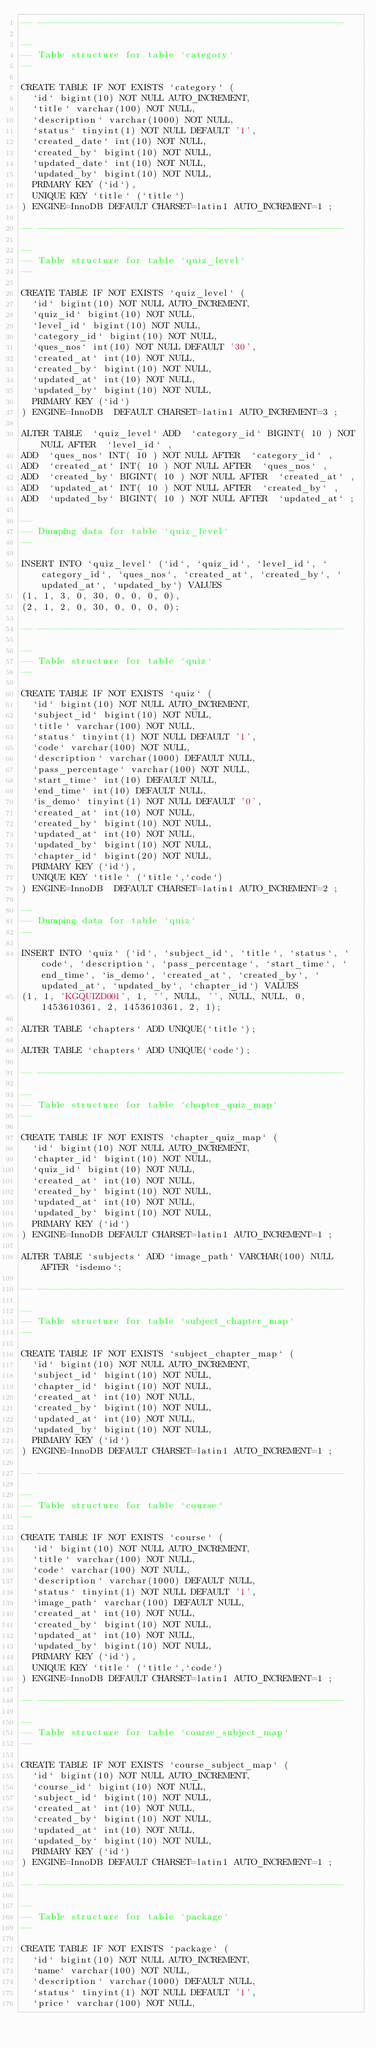<code> <loc_0><loc_0><loc_500><loc_500><_SQL_>-- --------------------------------------------------------

--
-- Table structure for table `category`
--

CREATE TABLE IF NOT EXISTS `category` (
  `id` bigint(10) NOT NULL AUTO_INCREMENT,
  `title` varchar(100) NOT NULL,
  `description` varchar(1000) NOT NULL,
  `status` tinyint(1) NOT NULL DEFAULT '1',
  `created_date` int(10) NOT NULL,
  `created_by` bigint(10) NOT NULL,
  `updated_date` int(10) NOT NULL,
  `updated_by` bigint(10) NOT NULL,
  PRIMARY KEY (`id`),
  UNIQUE KEY `title` (`title`)
) ENGINE=InnoDB DEFAULT CHARSET=latin1 AUTO_INCREMENT=1 ;

-- --------------------------------------------------------

--
-- Table structure for table `quiz_level`
--

CREATE TABLE IF NOT EXISTS `quiz_level` (
  `id` bigint(10) NOT NULL AUTO_INCREMENT,
  `quiz_id` bigint(10) NOT NULL,
  `level_id` bigint(10) NOT NULL,
  `category_id` bigint(10) NOT NULL,
  `ques_nos` int(10) NOT NULL DEFAULT '30',
  `created_at` int(10) NOT NULL,
  `created_by` bigint(10) NOT NULL,
  `updated_at` int(10) NOT NULL,
  `updated_by` bigint(10) NOT NULL,
  PRIMARY KEY (`id`)
) ENGINE=InnoDB  DEFAULT CHARSET=latin1 AUTO_INCREMENT=3 ;

ALTER TABLE  `quiz_level` ADD  `category_id` BIGINT( 10 ) NOT NULL AFTER  `level_id` ,
ADD  `ques_nos` INT( 10 ) NOT NULL AFTER  `category_id` ,
ADD  `created_at` INT( 10 ) NOT NULL AFTER  `ques_nos` ,
ADD  `created_by` BIGINT( 10 ) NOT NULL AFTER  `created_at` ,
ADD  `updated_at` INT( 10 ) NOT NULL AFTER  `created_by` ,
ADD  `updated_by` BIGINT( 10 ) NOT NULL AFTER  `updated_at` ;

--
-- Dumping data for table `quiz_level`
--

INSERT INTO `quiz_level` (`id`, `quiz_id`, `level_id`, `category_id`, `ques_nos`, `created_at`, `created_by`, `updated_at`, `updated_by`) VALUES
(1, 1, 3, 0, 30, 0, 0, 0, 0),
(2, 1, 2, 0, 30, 0, 0, 0, 0);

-- --------------------------------------------------------

--
-- Table structure for table `quiz`
--

CREATE TABLE IF NOT EXISTS `quiz` (
  `id` bigint(10) NOT NULL AUTO_INCREMENT,
  `subject_id` bigint(10) NOT NULL,
  `title` varchar(100) NOT NULL,
  `status` tinyint(1) NOT NULL DEFAULT '1',
  `code` varchar(100) NOT NULL,
  `description` varchar(1000) DEFAULT NULL,
  `pass_percentage` varchar(100) NOT NULL,
  `start_time` int(10) DEFAULT NULL,
  `end_time` int(10) DEFAULT NULL,
  `is_demo` tinyint(1) NOT NULL DEFAULT '0',
  `created_at` int(10) NOT NULL,
  `created_by` bigint(10) NOT NULL,
  `updated_at` int(10) NOT NULL,
  `updated_by` bigint(10) NOT NULL,
  `chapter_id` bigint(20) NOT NULL,
  PRIMARY KEY (`id`),
  UNIQUE KEY `title` (`title`,`code`)
) ENGINE=InnoDB  DEFAULT CHARSET=latin1 AUTO_INCREMENT=2 ;

--
-- Dumping data for table `quiz`
--

INSERT INTO `quiz` (`id`, `subject_id`, `title`, `status`, `code`, `description`, `pass_percentage`, `start_time`, `end_time`, `is_demo`, `created_at`, `created_by`, `updated_at`, `updated_by`, `chapter_id`) VALUES
(1, 1, 'KGQUIZD001', 1, '', NULL, '', NULL, NULL, 0, 1453610361, 2, 1453610361, 2, 1);

ALTER TABLE `chapters` ADD UNIQUE(`title`);

ALTER TABLE `chapters` ADD UNIQUE(`code`);

-- --------------------------------------------------------

--
-- Table structure for table `chapter_quiz_map`
--

CREATE TABLE IF NOT EXISTS `chapter_quiz_map` (
  `id` bigint(10) NOT NULL AUTO_INCREMENT,
  `chapter_id` bigint(10) NOT NULL,
  `quiz_id` bigint(10) NOT NULL,
  `created_at` int(10) NOT NULL,
  `created_by` bigint(10) NOT NULL,
  `updated_at` int(10) NOT NULL,
  `updated_by` bigint(10) NOT NULL,
  PRIMARY KEY (`id`)
) ENGINE=InnoDB DEFAULT CHARSET=latin1 AUTO_INCREMENT=1 ;

ALTER TABLE `subjects` ADD `image_path` VARCHAR(100) NULL AFTER `isdemo`;

-- --------------------------------------------------------

--
-- Table structure for table `subject_chapter_map`
--

CREATE TABLE IF NOT EXISTS `subject_chapter_map` (
  `id` bigint(10) NOT NULL AUTO_INCREMENT,
  `subject_id` bigint(10) NOT NULL,
  `chapter_id` bigint(10) NOT NULL,
  `created_at` int(10) NOT NULL,
  `created_by` bigint(10) NOT NULL,
  `updated_at` int(10) NOT NULL,
  `updated_by` bigint(10) NOT NULL,
  PRIMARY KEY (`id`)
) ENGINE=InnoDB DEFAULT CHARSET=latin1 AUTO_INCREMENT=1 ;

-- --------------------------------------------------------

--
-- Table structure for table `course`
--

CREATE TABLE IF NOT EXISTS `course` (
  `id` bigint(10) NOT NULL AUTO_INCREMENT,
  `title` varchar(100) NOT NULL,
  `code` varchar(100) NOT NULL,
  `description` varchar(1000) DEFAULT NULL,
  `status` tinyint(1) NOT NULL DEFAULT '1',
  `image_path` varchar(100) DEFAULT NULL,
  `created_at` int(10) NOT NULL,
  `created_by` bigint(10) NOT NULL,
  `updated_at` int(10) NOT NULL,
  `updated_by` bigint(10) NOT NULL,
  PRIMARY KEY (`id`),
  UNIQUE KEY `title` (`title`,`code`)
) ENGINE=InnoDB DEFAULT CHARSET=latin1 AUTO_INCREMENT=1 ;

-- --------------------------------------------------------

--
-- Table structure for table `course_subject_map`
--

CREATE TABLE IF NOT EXISTS `course_subject_map` (
  `id` bigint(10) NOT NULL AUTO_INCREMENT,
  `course_id` bigint(10) NOT NULL,
  `subject_id` bigint(10) NOT NULL,
  `created_at` int(10) NOT NULL,
  `created_by` bigint(10) NOT NULL,
  `updated_at` int(10) NOT NULL,
  `updated_by` bigint(10) NOT NULL,
  PRIMARY KEY (`id`)
) ENGINE=InnoDB DEFAULT CHARSET=latin1 AUTO_INCREMENT=1 ;

-- --------------------------------------------------------

--
-- Table structure for table `package`
--

CREATE TABLE IF NOT EXISTS `package` (
  `id` bigint(10) NOT NULL AUTO_INCREMENT,
  `name` varchar(100) NOT NULL,
  `description` varchar(1000) DEFAULT NULL,
  `status` tinyint(1) NOT NULL DEFAULT '1',
  `price` varchar(100) NOT NULL,</code> 